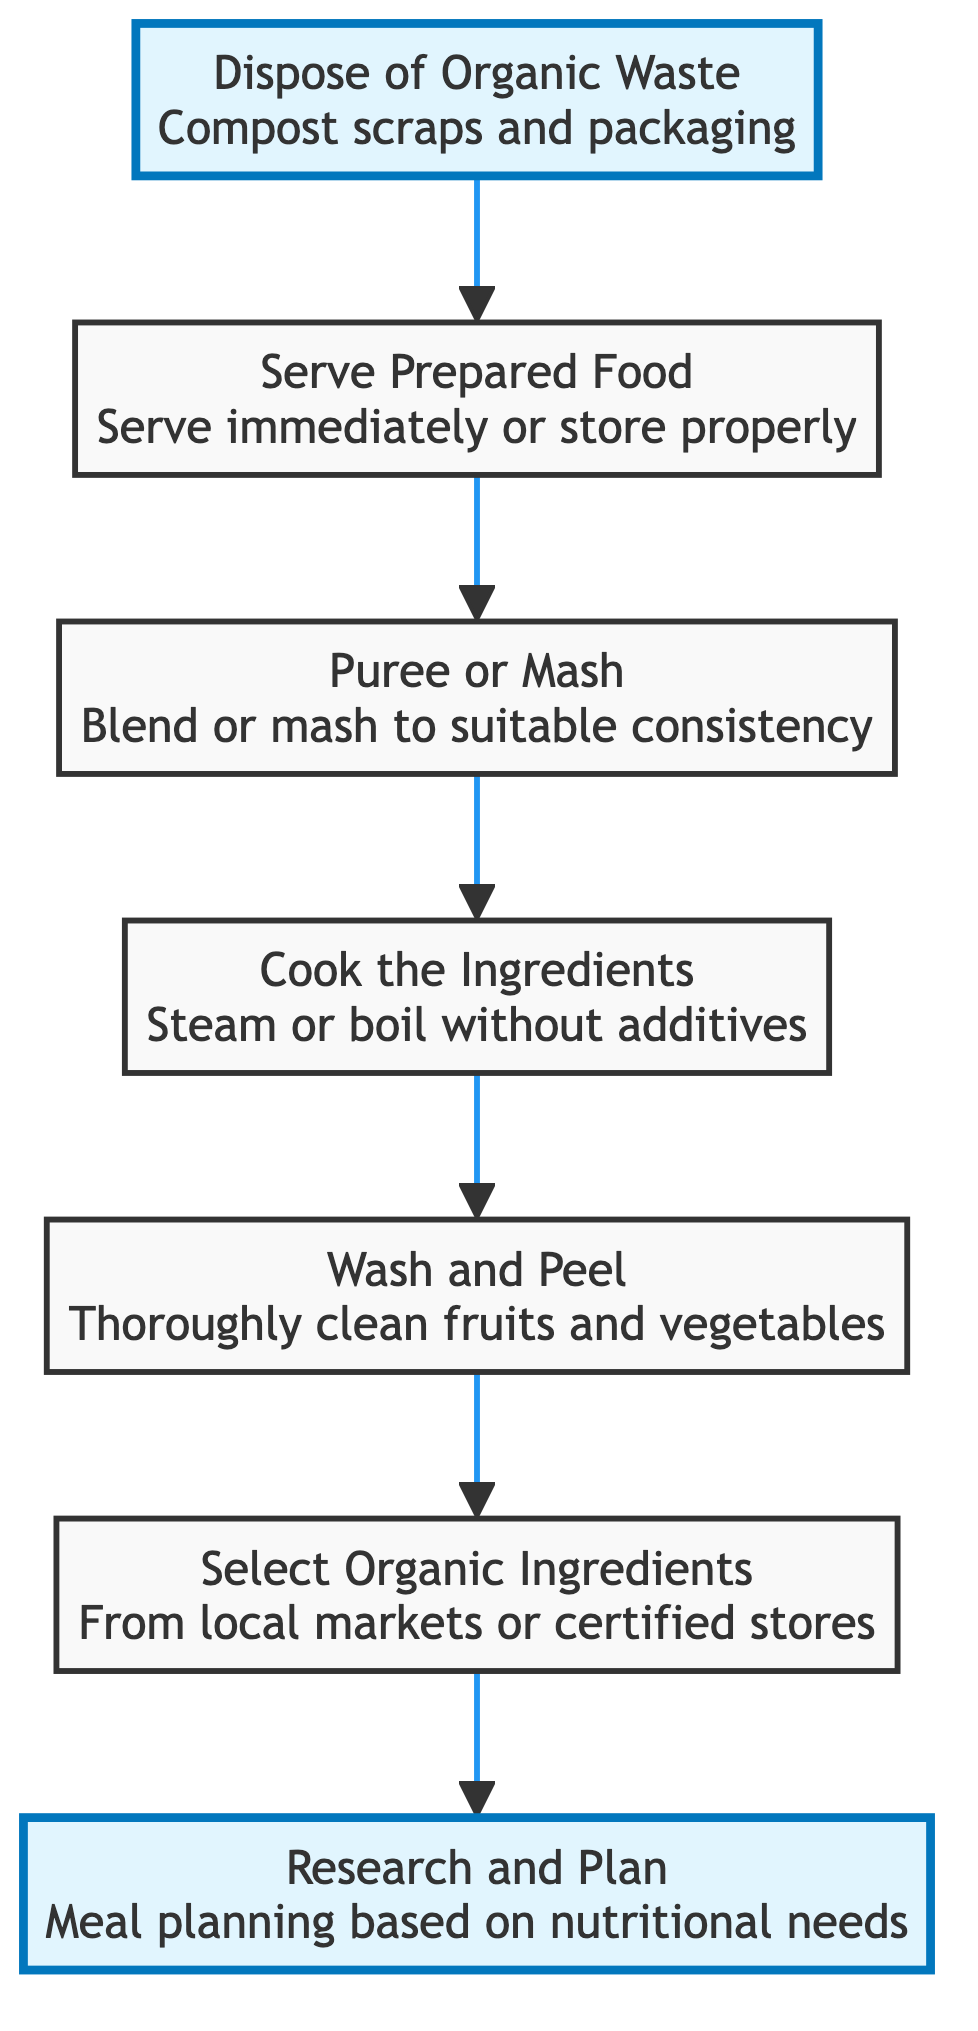What is the first step in preparing organic baby food? The first step in the flow chart is "Research and Plan," indicating that meal planning based on nutritional needs should be done initially.
Answer: Research and Plan How many steps are there in total? The diagram features a total of 7 steps, from "Research and Plan" to "Dispose of Organic Waste."
Answer: 7 What action follows "Select Organic Ingredients"? The action that follows "Select Organic Ingredients" in the flow chart is "Wash and Peel." This indicates that after choosing the ingredients, they need to be washed and peeled.
Answer: Wash and Peel What do you do with organic waste according to the diagram? According to the diagram, organic waste should be disposed of by composting scraps and packaging materials.
Answer: Compost Which step involves removing any traces of pesticides? The step that involves removing any traces of pesticides is "Wash and Peel," where thorough washing and peeling of fruits and vegetables are emphasized.
Answer: Wash and Peel What is the last action after "Serve Prepared Food"? The last action in the flowchart after "Serve Prepared Food" is "Dispose of Organic Waste," indicating that after serving the food, one should deal with the organic waste generated.
Answer: Dispose of Organic Waste If you skip "Cook the Ingredients," what would you miss out on? By skipping "Cook the Ingredients," you would miss the important task of steaming or boiling ingredients, which is essential for ensuring they are tender and safe for the baby.
Answer: Cooking tendency What is the relationship between "Puree or Mash" and "Cook the Ingredients"? "Puree or Mash" follows "Cook the Ingredients," meaning that after the ingredients are cooked, they must be pureed or mashed to reach a suitable consistency for the baby.
Answer: Follows 